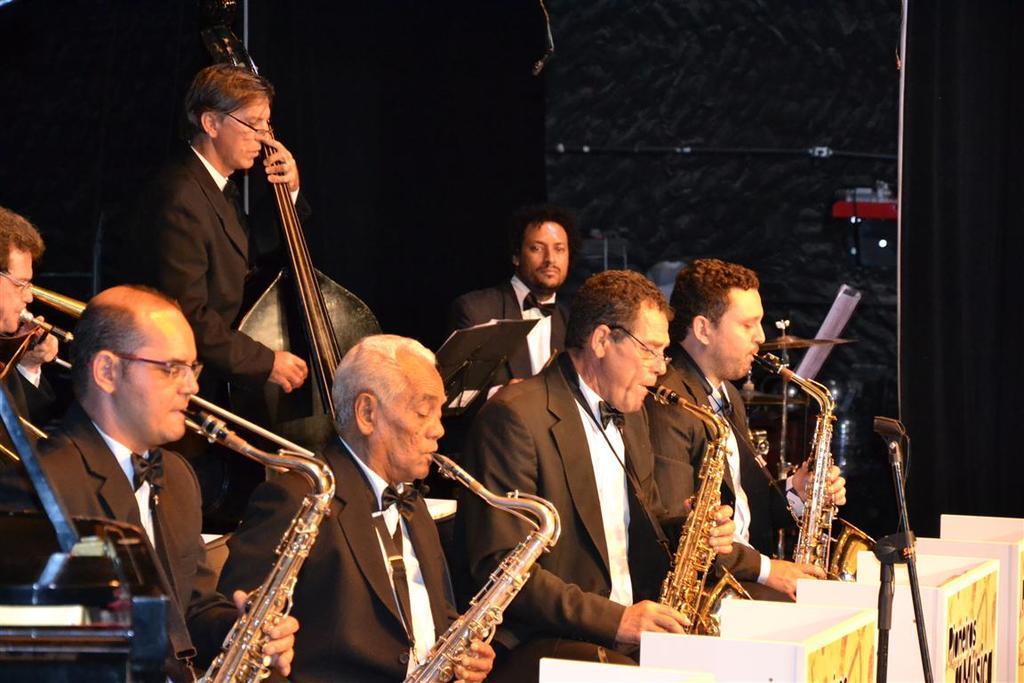Please provide a concise description of this image. In the image in the center, we can see a few people are sitting and one person is standing and they are playing some musical instruments. In front of them, we can see banners and a microphone. In the background there is a wall and a few other objects. 